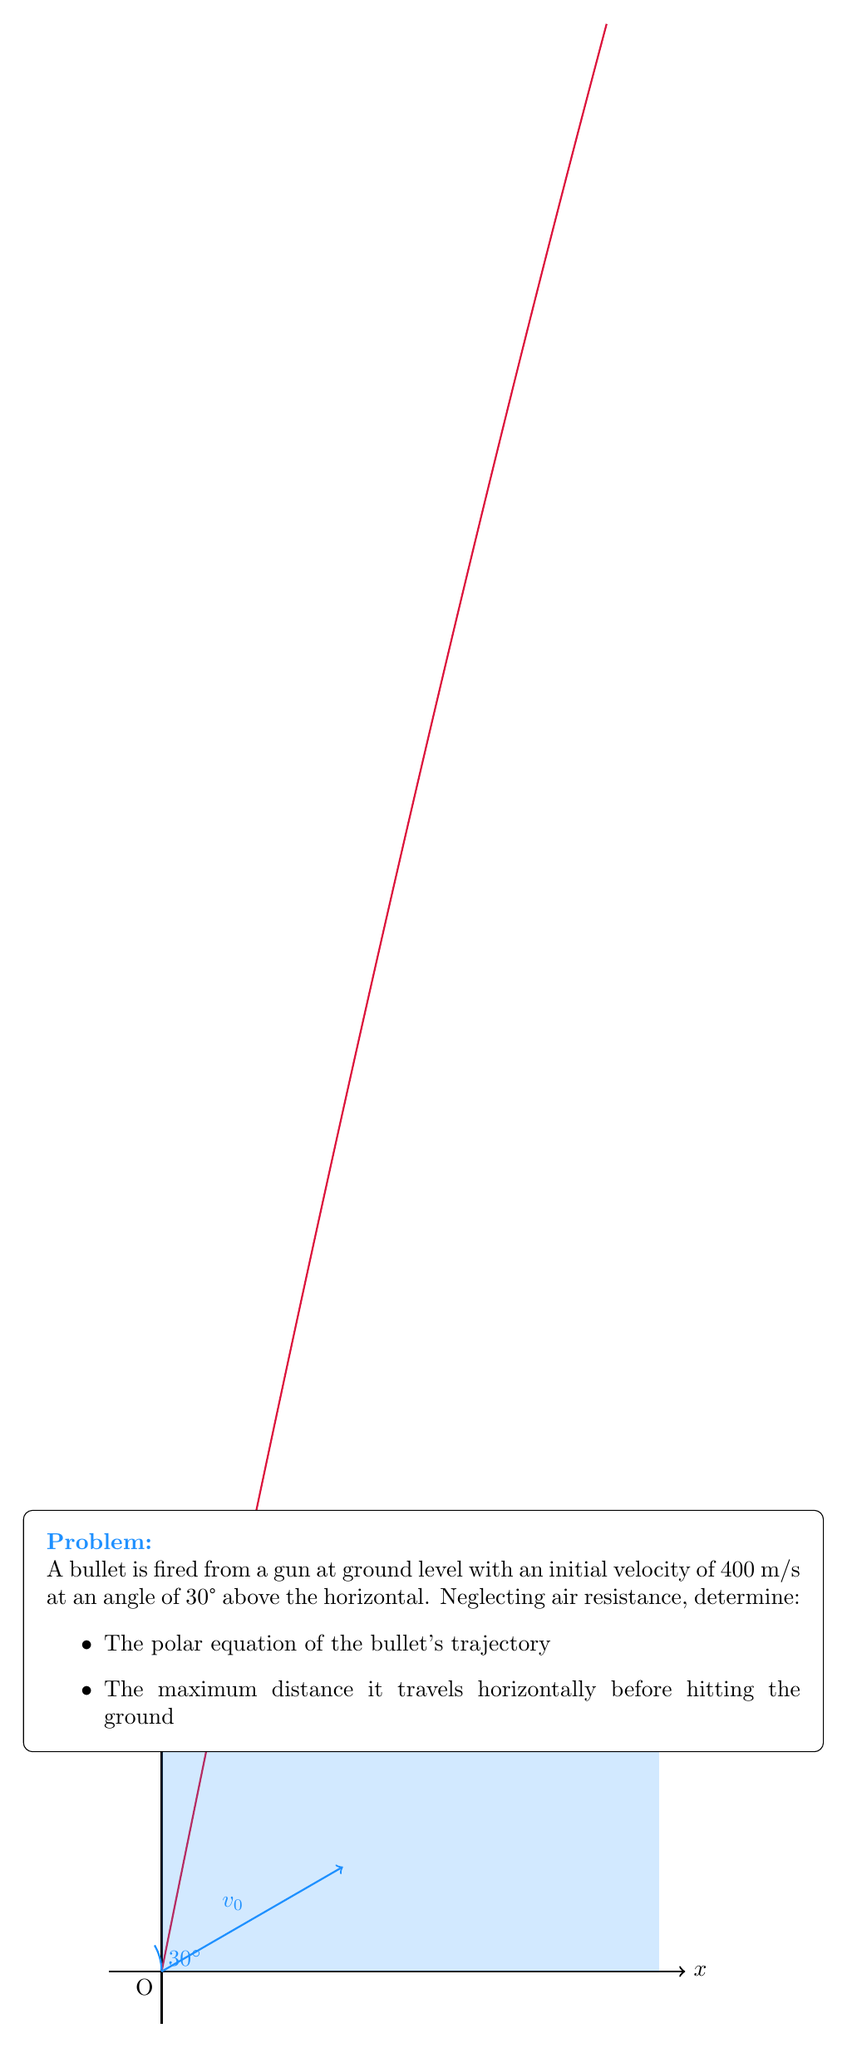Give your solution to this math problem. Let's approach this problem step-by-step using polar coordinates:

1) In polar coordinates, we can express the position of the bullet as:
   $$r = r(\theta)$$
   where $r$ is the distance from the origin and $\theta$ is the angle from the horizontal.

2) The parametric equations of motion for a projectile are:
   $$x = v_0t\cos(30°)$$
   $$y = v_0t\sin(30°) - \frac{1}{2}gt^2$$
   where $v_0 = 400$ m/s, $g = 9.8$ m/s².

3) We can convert these to polar form:
   $$r\cos(\theta) = v_0t\cos(30°)$$
   $$r\sin(\theta) = v_0t\sin(30°) - \frac{1}{2}gt^2$$

4) Dividing the second equation by the first:
   $$\tan(\theta) = \frac{v_0t\sin(30°) - \frac{1}{2}gt^2}{v_0t\cos(30°)}$$

5) Simplifying:
   $$\tan(\theta) = \tan(30°) - \frac{g}{2v_0^2\cos^2(30°)}r$$

6) This can be rearranged to give the polar equation:
   $$r = \frac{2v_0^2\cos^2(30°)}{g}(\tan(30°) - \tan(\theta))$$

7) To find the maximum horizontal distance, we need to find when $y = 0$:
   $$0 = v_0t\sin(30°) - \frac{1}{2}gt^2$$

8) Solving this quadratic equation:
   $$t = \frac{2v_0\sin(30°)}{g}$$

9) The horizontal distance is then:
   $$R = v_0t\cos(30°) = \frac{v_0^2\sin(60°)}{g}$$

10) Substituting the values:
    $$R = \frac{400^2 \cdot \sin(60°)}{9.8} \approx 14,140.39 \text{ m}$$
Answer: Polar equation: $r = \frac{2(400)^2\cos^2(30°)}{9.8}(\tan(30°) - \tan(\theta))$; Maximum horizontal distance: 14,140 m 